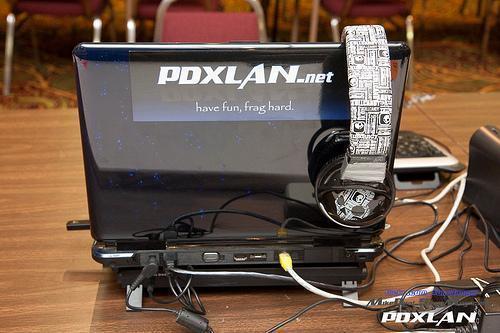How many people are typing computer?
Give a very brief answer. 0. 